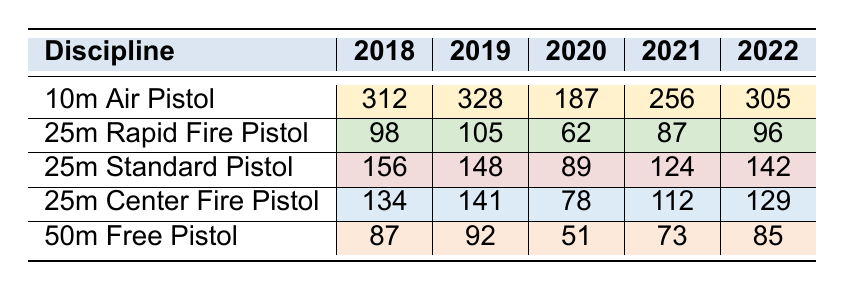What was the highest participation rate in the 10m Air Pistol discipline? The 10m Air Pistol participation rates from 2018 to 2022 are: 312, 328, 187, 256, 305. The highest value is 328 (in 2019).
Answer: 328 What was the lowest participation rate for the 50m Free Pistol? The participation rates for the 50m Free Pistol are 87, 92, 51, 73, 85. The lowest value is 51 (in 2020).
Answer: 51 Which discipline had a participation increase from 2020 to 2021? I will look at participation rates for each discipline: 10m Air Pistol (187 to 256), 25m Rapid Fire Pistol (62 to 87), 25m Standard Pistol (89 to 124), and 25m Center Fire Pistol (78 to 112) all increased. The 50m Free Pistol decreased (51 to 73).
Answer: 10m Air Pistol, 25m Rapid Fire Pistol, 25m Standard Pistol, 25m Center Fire Pistol What is the average participation rate for the 25m Standard Pistol over the years? The rates are 156, 148, 89, 124, 142. Adding these gives 659. Divide by 5 for the average: 659/5 = 131.8.
Answer: 131.8 Did the participation in the 25m Center Fire Pistol increase from 2018 to 2022? The rates for 25m Center Fire Pistol from 2018 to 2022 are 134, 141, 78, 112, and 129. The values show a decrease from 2018 to 2020, but an increase from 2020 to 2022, so overall it did not consistently increase.
Answer: No Which discipline had the highest participation in 2021? Comparing participation rates in 2021 for all disciplines: 10m Air Pistol (256), 25m Rapid Fire Pistol (87), 25m Standard Pistol (124), 25m Center Fire Pistol (112), and 50m Free Pistol (73). The highest is 256 for 10m Air Pistol.
Answer: 10m Air Pistol What was the total participation across all disciplines in 2022? The participation rates in 2022 are 305 (10m Air Pistol) + 96 (25m Rapid Fire Pistol) + 142 (25m Standard Pistol) + 129 (25m Center Fire Pistol) + 85 (50m Free Pistol). Adding these gives 305 + 96 + 142 + 129 + 85 = 757.
Answer: 757 Was the participation in 25m Standard Pistol greater than 25m Rapid Fire Pistol in 2020? In 2020, the participation rates are 89 for 25m Standard Pistol and 62 for 25m Rapid Fire Pistol. Since 89 is greater than 62, participation was higher in 25m Standard Pistol.
Answer: Yes What trend can be observed for the 10m Air Pistol from 2018 to 2022? The participation rates for 10m Air Pistol are: 312, 328, 187, 256, 305. There is an initial increase from 2018 to 2019, followed by a drop in 2020, recovery in 2021, then a slight decrease in 2022.
Answer: Fluctuating trend What is the percentage decrease in participation for the 50m Free Pistol from 2019 to 2020? The participation rates are 92 (2019) and 51 (2020). The decrease is 92 - 51 = 41. To find the percentage decrease: (41/92) * 100 = 44.57%.
Answer: 44.57% 